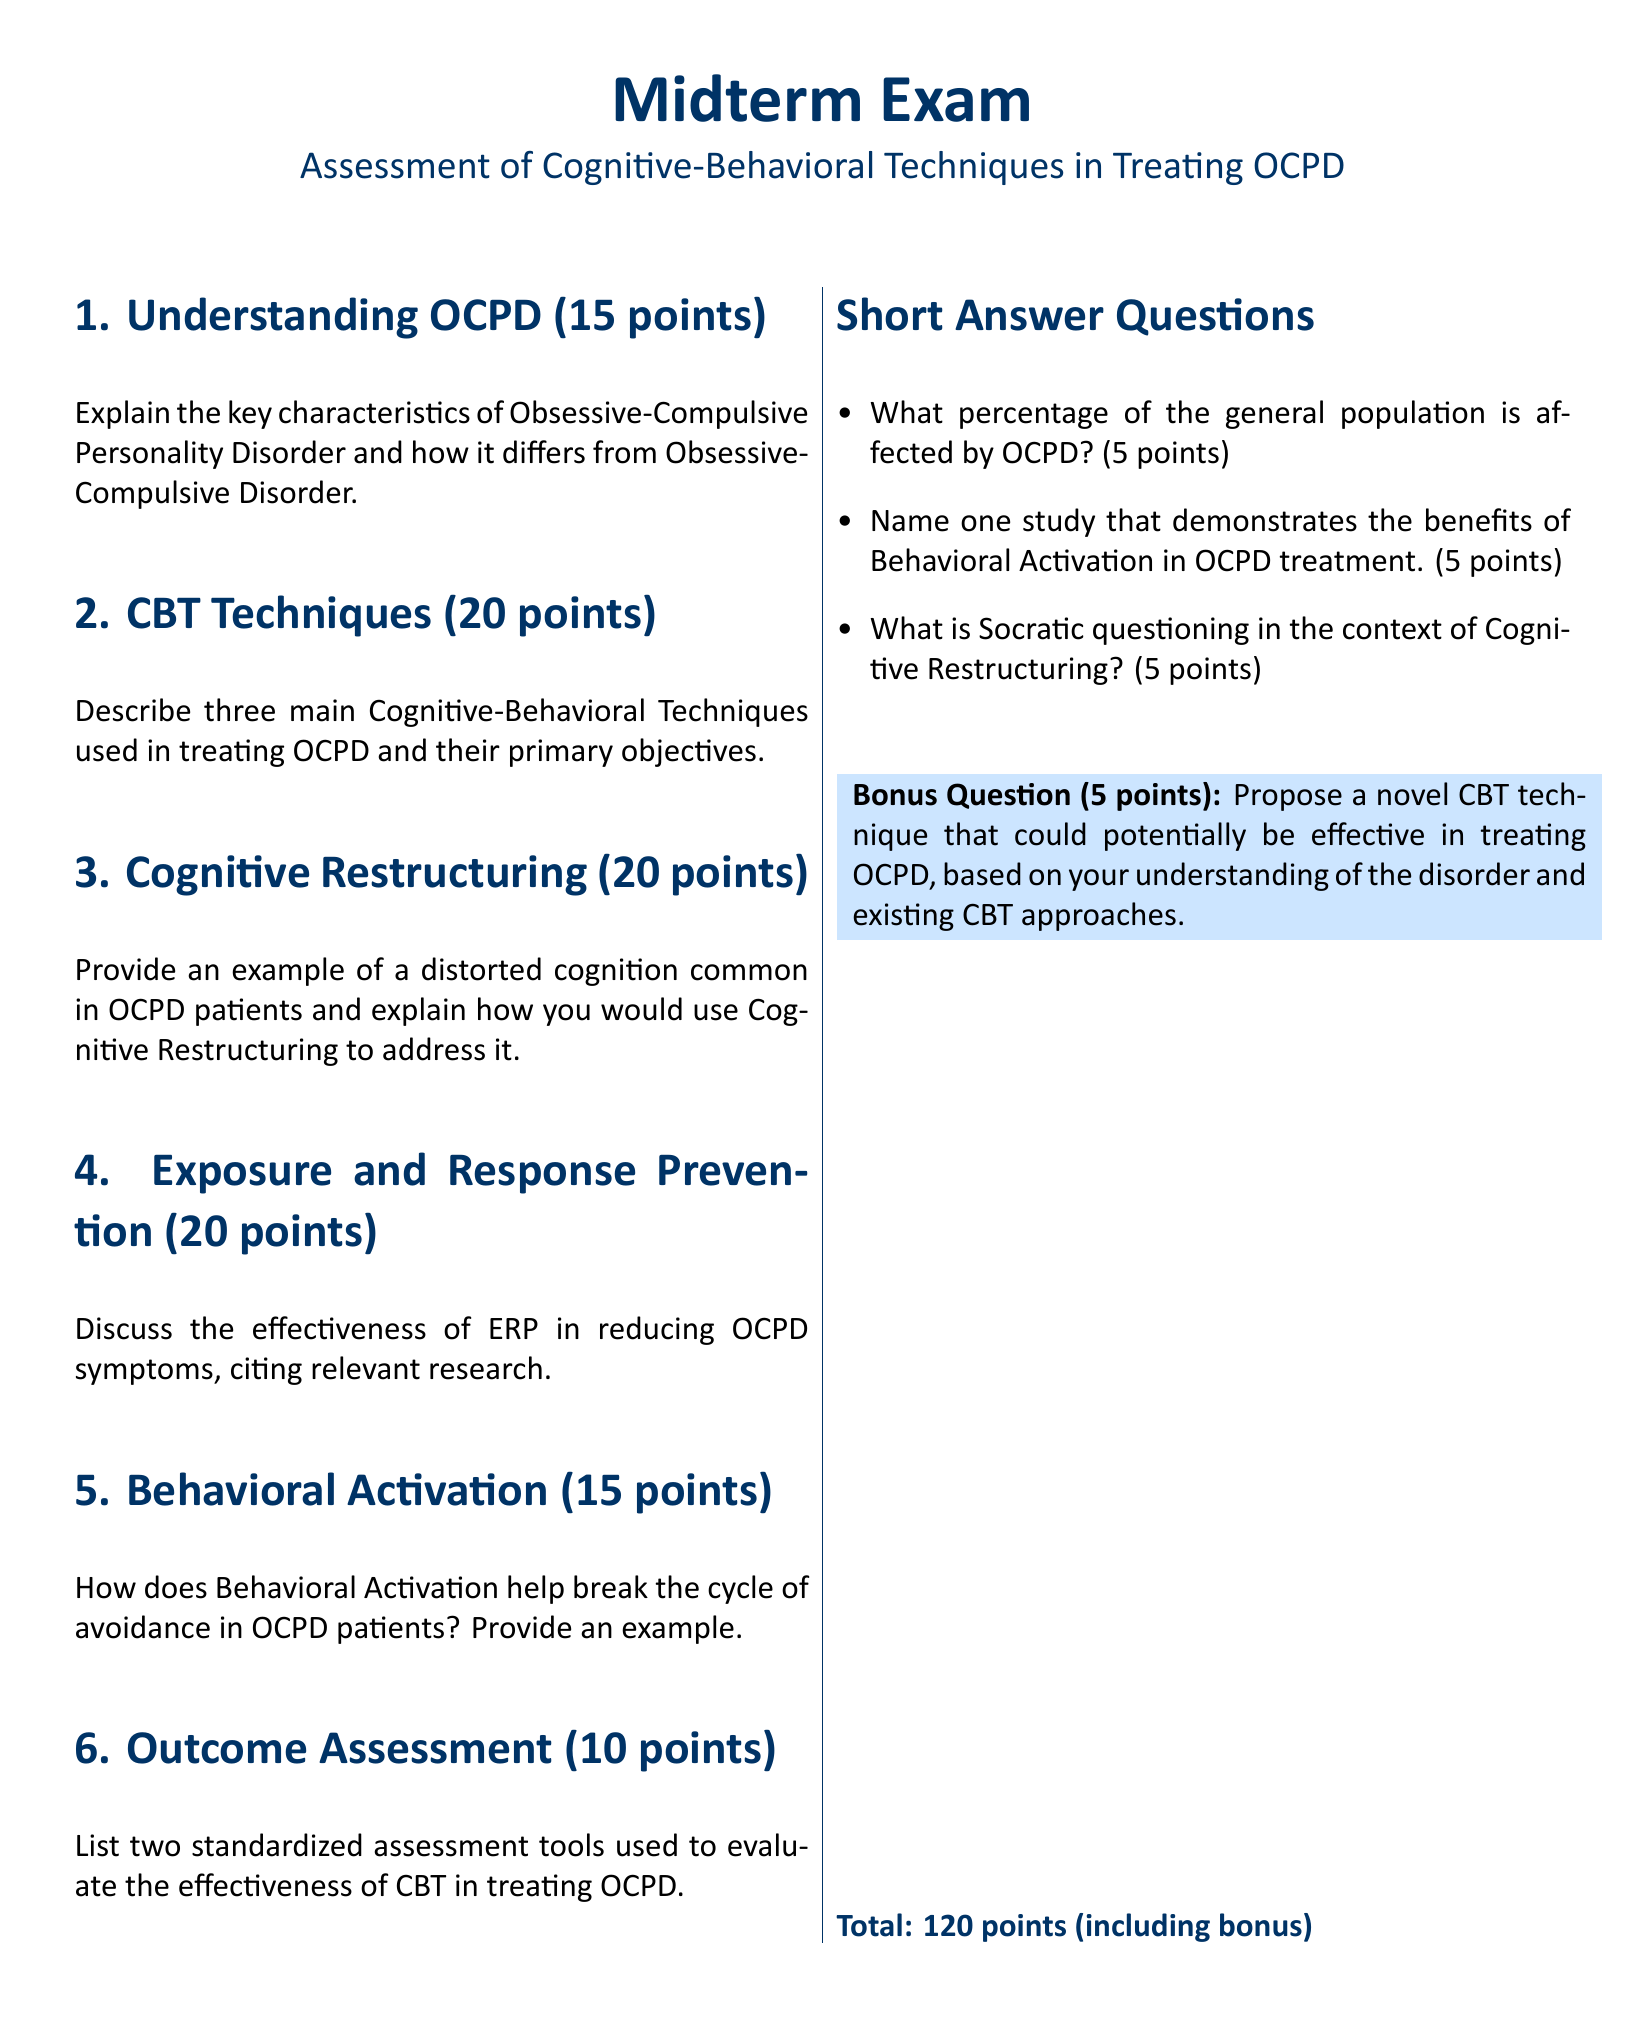What is the total number of points for the midterm exam? The total number of points is stated at the end of the exam document, which includes the points for the bonus question as well.
Answer: 120 points What section discusses Cognitive Restructuring? The document outlines different sections, and the title of the section covering Cognitive Restructuring is clearly indicated.
Answer: Section 3 How many points is the Bonus Question worth? The Bonus Question is specifically mentioned with its corresponding point value in the document.
Answer: 5 points What percentage of the general population is affected by OCPD? This question refers to a specific point value related to short answer questions listed in the exam.
Answer: 5 points Name one technique discussed in the CBT Techniques section. The document specifies that several main techniques are described in this section, focusing on Cognitive-Behavioral therapy methods.
Answer: Three main Cognitive-Behavioral Techniques What is the points value assigned to the Exposure and Response Prevention section? The points assigned to each section is clearly listed alongside the section titles throughout the document.
Answer: 20 points What example does the Behavioral Activation section ask for? The document indicates a specific focus on how Behavioral Activation helps break the cycle of avoidance in OCPD patients.
Answer: Example Name one study related to Behavioral Activation in OCPD treatment. This is directly stated as part of the short answer questions included in the exam document.
Answer: 5 points What technique is proposed in the Bonus Question? The Bonus Question asks for a novel CBT technique specifically related to treating OCPD, which is part of the special prompt included.
Answer: Novel CBT technique 